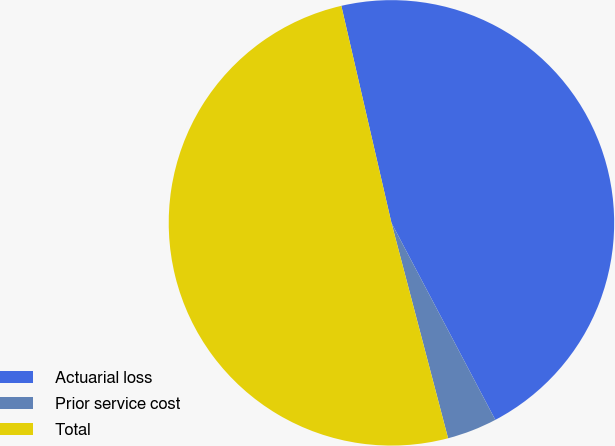Convert chart to OTSL. <chart><loc_0><loc_0><loc_500><loc_500><pie_chart><fcel>Actuarial loss<fcel>Prior service cost<fcel>Total<nl><fcel>45.89%<fcel>3.63%<fcel>50.48%<nl></chart> 